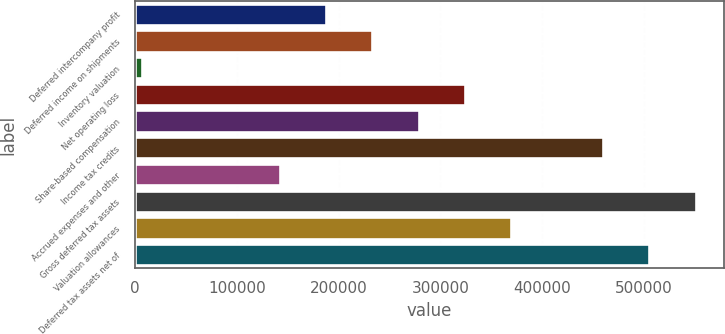Convert chart to OTSL. <chart><loc_0><loc_0><loc_500><loc_500><bar_chart><fcel>Deferred intercompany profit<fcel>Deferred income on shipments<fcel>Inventory valuation<fcel>Net operating loss<fcel>Share-based compensation<fcel>Income tax credits<fcel>Accrued expenses and other<fcel>Gross deferred tax assets<fcel>Valuation allowances<fcel>Deferred tax assets net of<nl><fcel>187815<fcel>233208<fcel>6245<fcel>323992<fcel>278600<fcel>460170<fcel>142422<fcel>550955<fcel>369385<fcel>505562<nl></chart> 